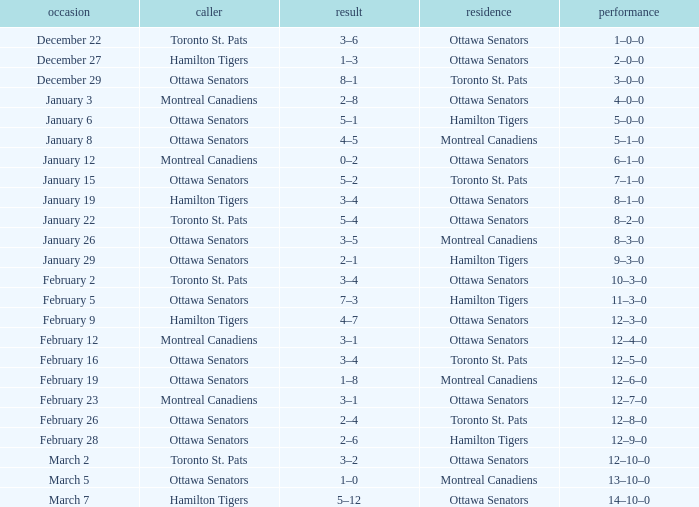Who was the home team when the vistor team was the Montreal Canadiens on February 12? Ottawa Senators. 